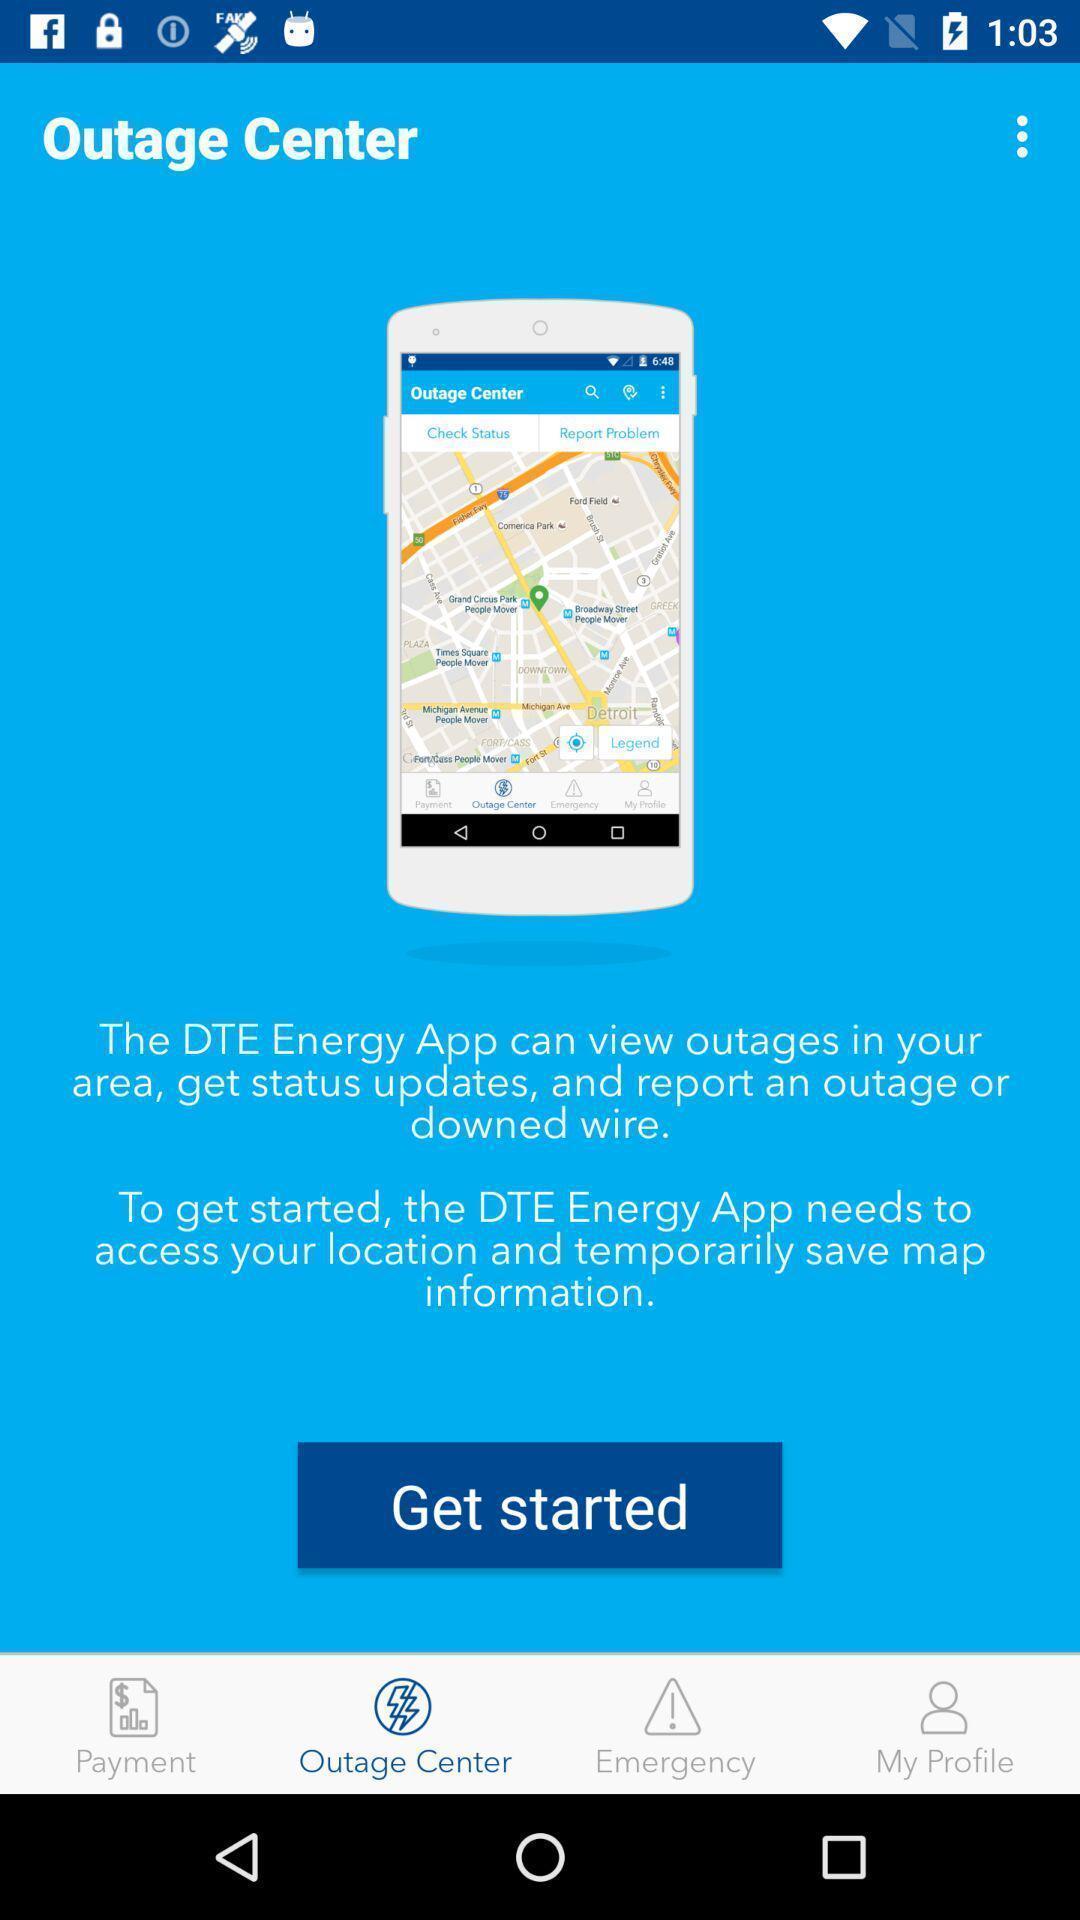Summarize the information in this screenshot. Welcome page of an bills payment application. 